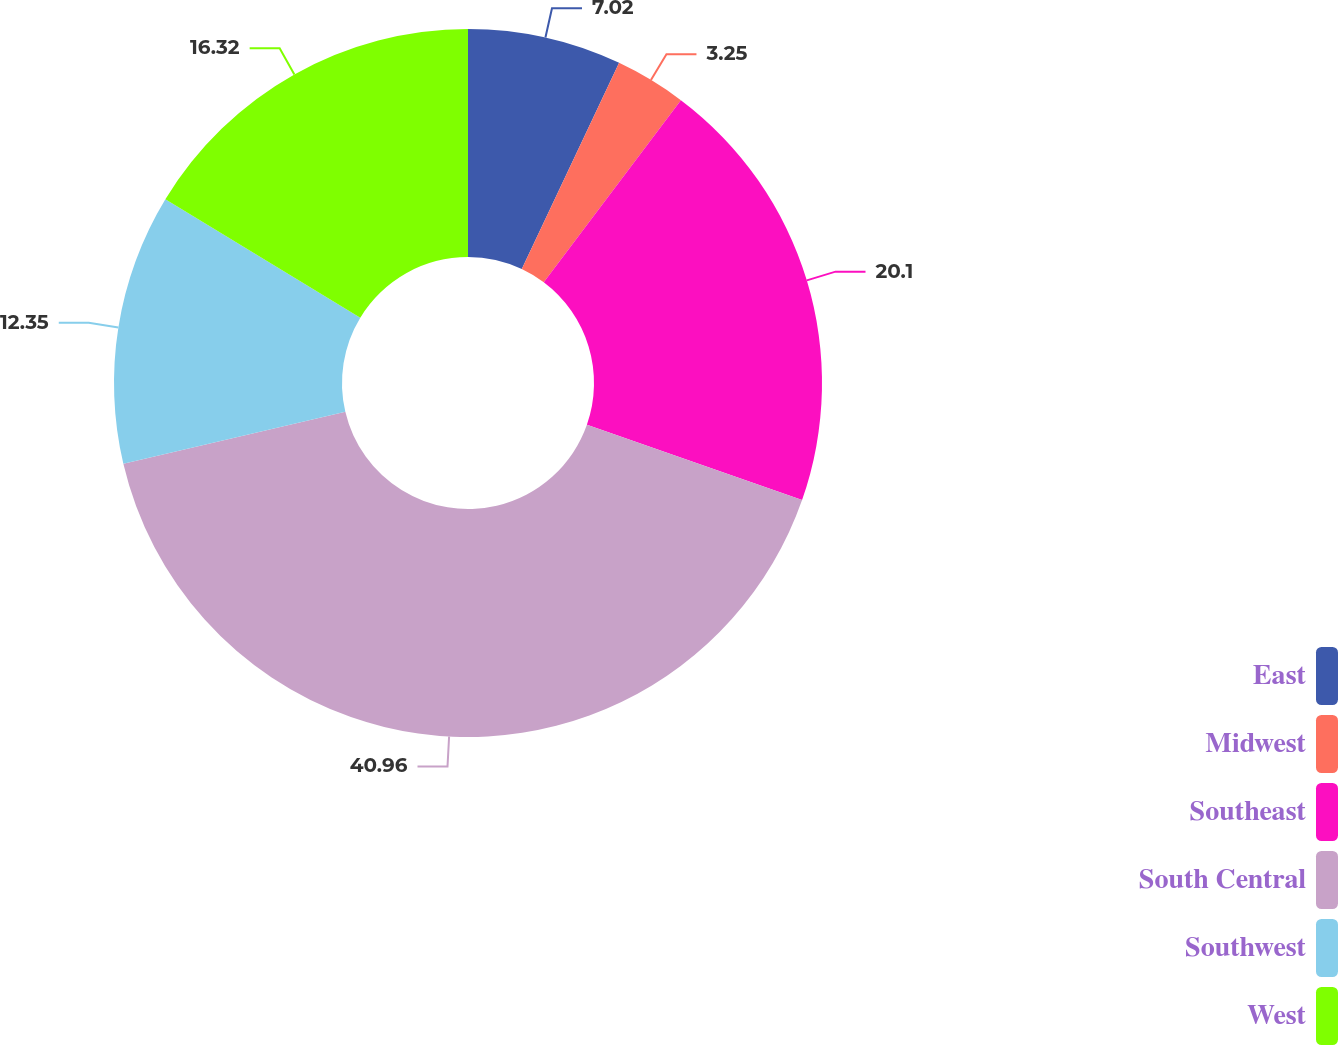Convert chart to OTSL. <chart><loc_0><loc_0><loc_500><loc_500><pie_chart><fcel>East<fcel>Midwest<fcel>Southeast<fcel>South Central<fcel>Southwest<fcel>West<nl><fcel>7.02%<fcel>3.25%<fcel>20.1%<fcel>40.97%<fcel>12.35%<fcel>16.32%<nl></chart> 